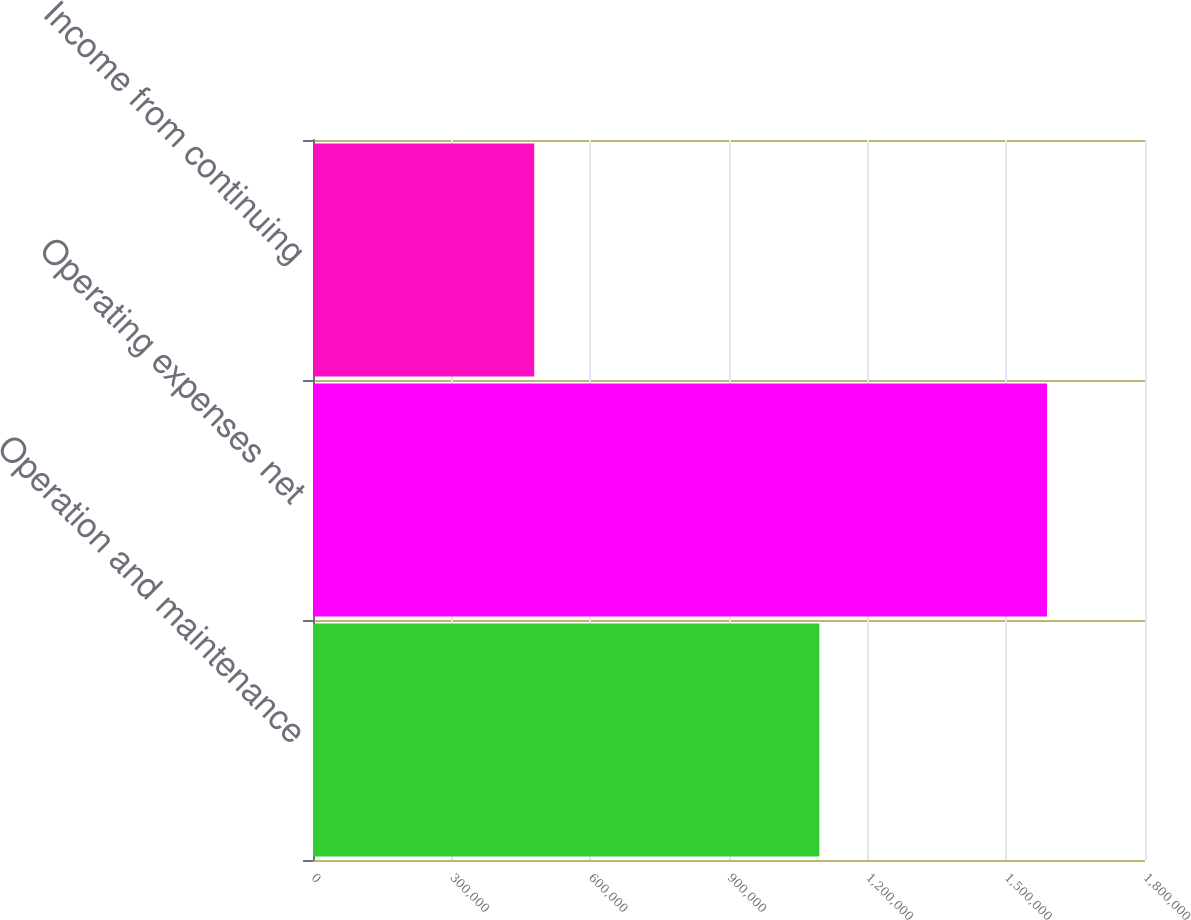<chart> <loc_0><loc_0><loc_500><loc_500><bar_chart><fcel>Operation and maintenance<fcel>Operating expenses net<fcel>Income from continuing<nl><fcel>1.09545e+06<fcel>1.58796e+06<fcel>478629<nl></chart> 